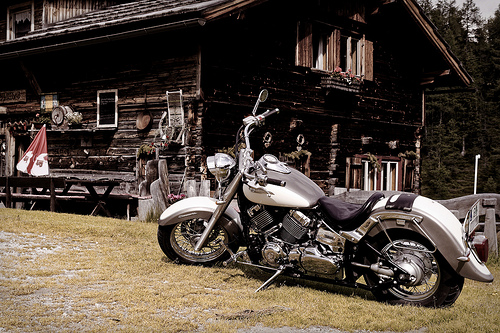<image>
Is there a umbrella in front of the motorcycle? Yes. The umbrella is positioned in front of the motorcycle, appearing closer to the camera viewpoint. 